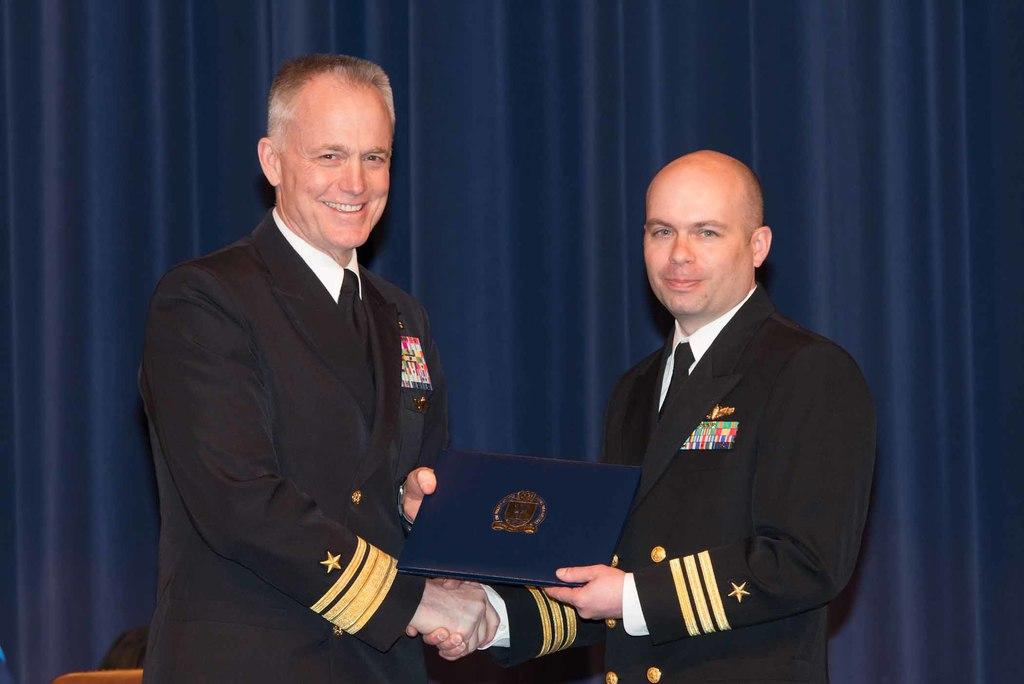What are the people in the image doing with their hands? The people in the image are holding objects. What can be seen in the background of the image? There is a background with some cloth in the image. What is visible at the bottom of the image? There are objects visible at the bottom of the image. What type of mark can be seen on the cloth in the image? There is no mark visible on the cloth in the image. What kind of trade is being conducted in the image? There is no indication of any trade being conducted in the image. 